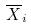<formula> <loc_0><loc_0><loc_500><loc_500>\overline { X } _ { i }</formula> 